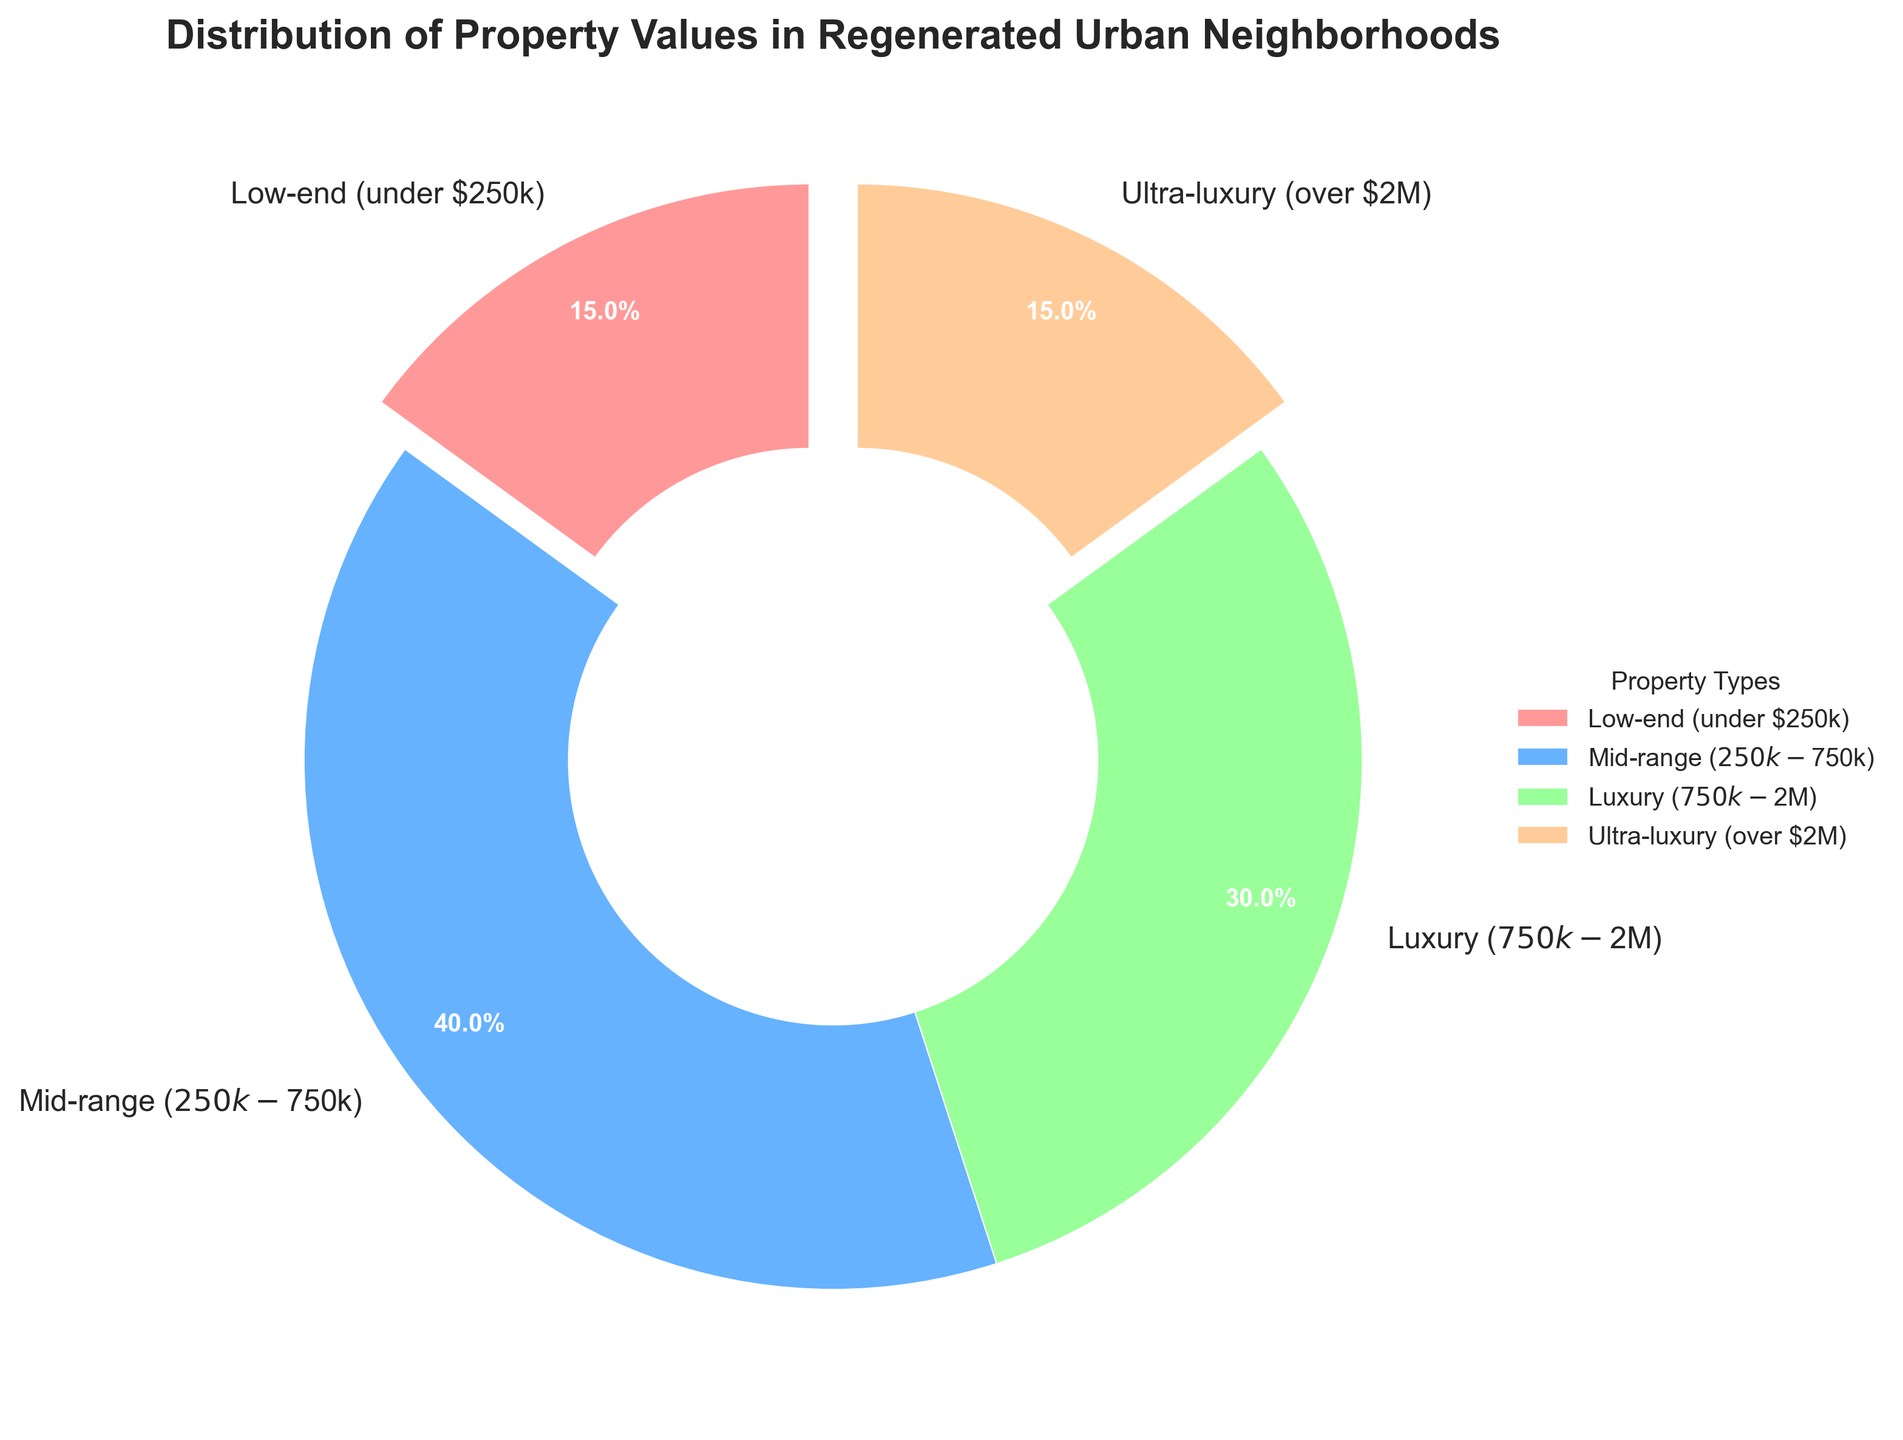Which property type has the highest percentage in the pie chart? The pie chart shows the mid-range ($250k-$750k) property type with the highest percentage, which is 40%.
Answer: Mid-range What is the combined percentage of low-end and ultra-luxury properties? Adding the percentages of low-end (15%) and ultra-luxury (15%) properties gives 15% + 15% = 30%.
Answer: 30% How does the percentage of luxury ($750k-$2M) properties compare to the percentage of mid-range ($250k-$750k) properties? The percentage of luxury properties is 30%, while the percentage of mid-range properties is 40%. Thus, the mid-range properties have a higher percentage than luxury properties.
Answer: Mid-range is higher What is the visual characteristic of the slices representing low-end and ultra-luxury properties? The slices representing low-end and ultra-luxury properties are exploded slightly from the pie chart for emphasis.
Answer: Exploded If the pie chart represents a total of 200 properties, how many properties fall into the luxury category? If 30% of 200 properties are in the luxury category, then 0.3 * 200 = 60 properties are in the luxury category.
Answer: 60 Which property type shares the same percentage and what is it? The low-end (under $250k) and ultra-luxury (over $2M) property types both share the same percentage, which is 15%.
Answer: Low-end and Ultra-luxury; 15% What is the difference in percentage points between the lowest and the highest property types? The highest percentage is mid-range (40%) and the lowest are low-end and ultra-luxury (both 15%). The difference is 40% - 15% = 25 percentage points.
Answer: 25 percentage points What color represents the mid-range properties in the pie chart? The mid-range properties are represented by the blue color in the pie chart.
Answer: Blue 